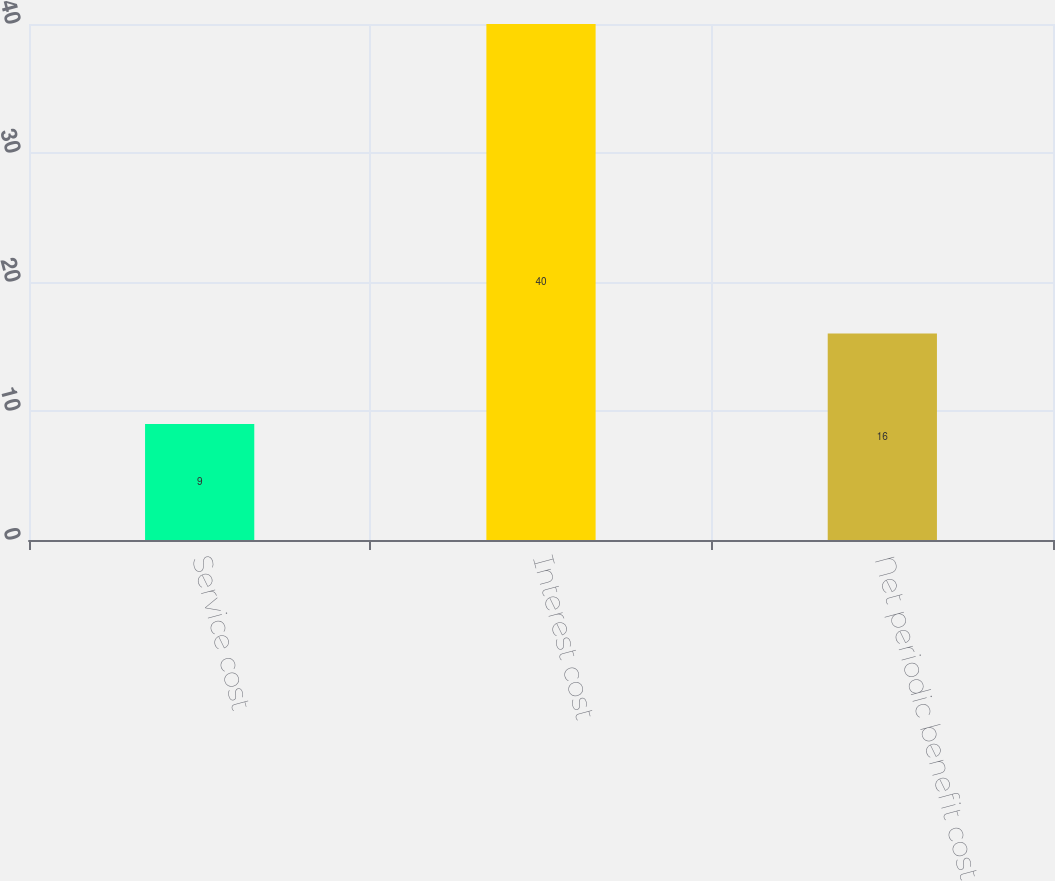<chart> <loc_0><loc_0><loc_500><loc_500><bar_chart><fcel>Service cost<fcel>Interest cost<fcel>Net periodic benefit cost<nl><fcel>9<fcel>40<fcel>16<nl></chart> 